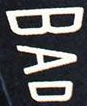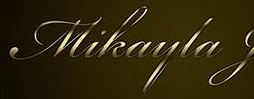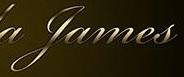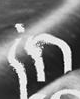What words can you see in these images in sequence, separated by a semicolon? BAD; Mikayla; James; in 